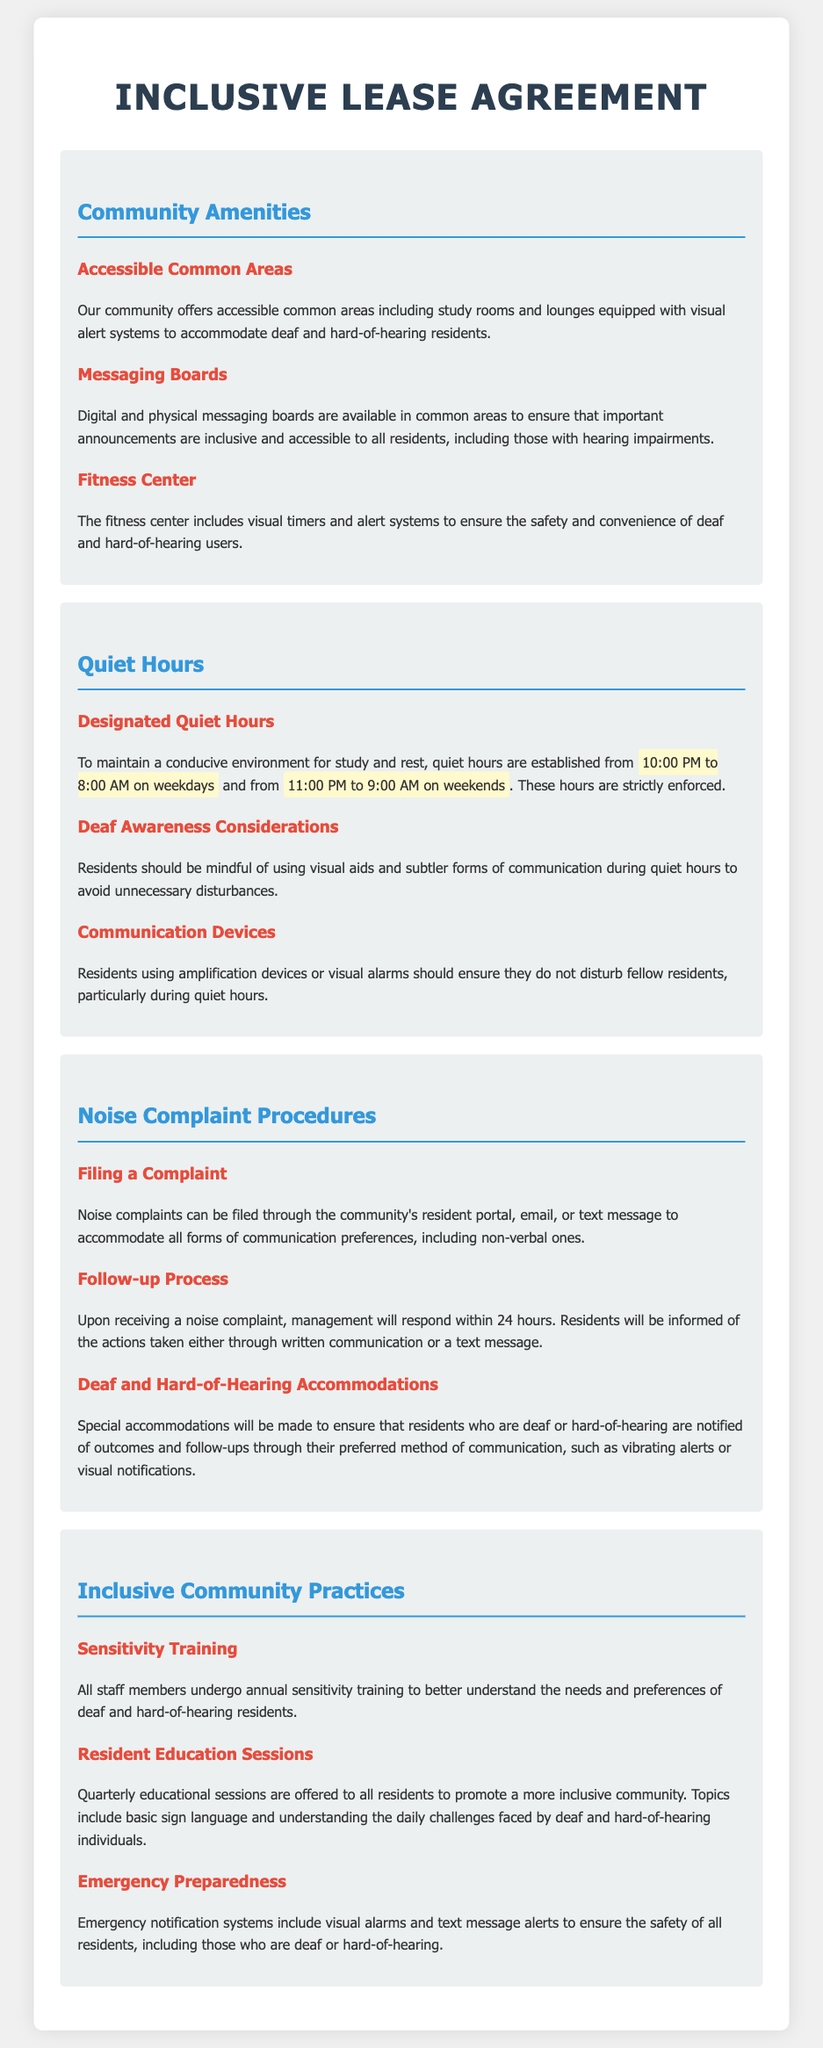What are the designated quiet hours on weekdays? The designated quiet hours are from 10:00 PM to 8:00 AM on weekdays.
Answer: 10:00 PM to 8:00 AM What visual aids are mentioned in the context of quiet hours? The document specifies that residents should use visual aids during quiet hours to avoid disturbances.
Answer: Visual aids What type of equipment is provided in the fitness center for deaf residents? The fitness center includes visual timers and alert systems.
Answer: Visual timers and alert systems How long does management take to respond to a noise complaint? Management will respond within 24 hours of receiving a noise complaint.
Answer: 24 hours What training do staff members undergo annually? Staff members undergo annual sensitivity training.
Answer: Sensitivity training What is the purpose of digital and physical messaging boards? The messaging boards ensure that important announcements are inclusive and accessible to all residents.
Answer: Inclusive and accessible announcements What is included in the emergency notification systems? Emergency notification systems include visual alarms and text message alerts.
Answer: Visual alarms and text message alerts During what times are quiet hours enforced on weekends? Quiet hours on weekends are enforced from 11:00 PM to 9:00 AM.
Answer: 11:00 PM to 9:00 AM What accommodations are made for residents who are hard-of-hearing when filing a complaint? Residents can file complaints through various communication preferences, including non-verbal ones.
Answer: Various communication preferences 